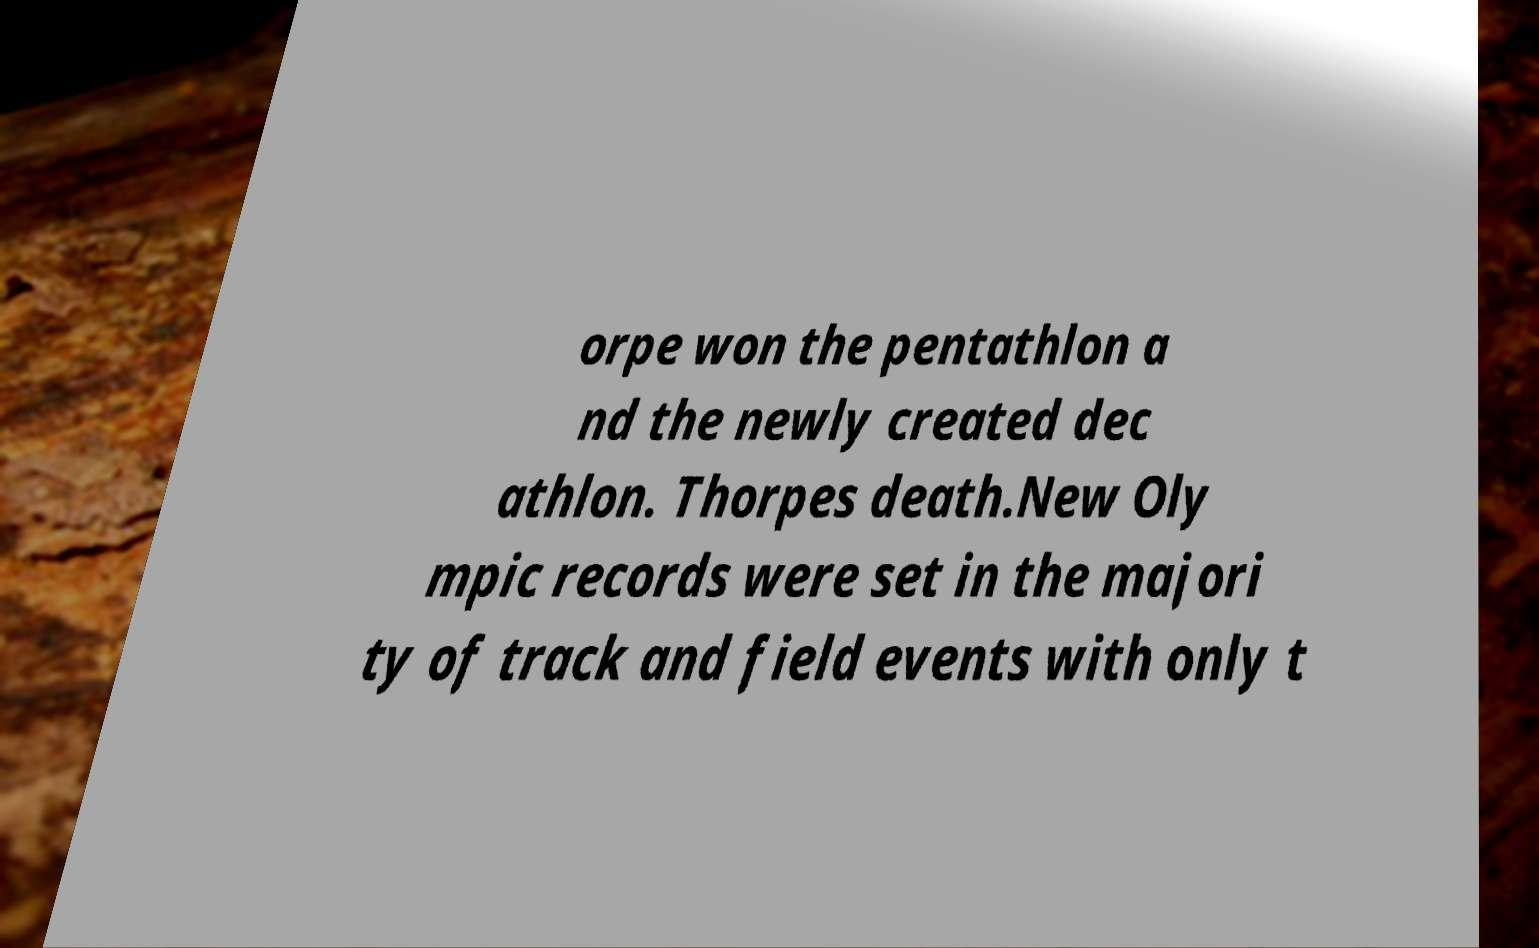Please read and relay the text visible in this image. What does it say? orpe won the pentathlon a nd the newly created dec athlon. Thorpes death.New Oly mpic records were set in the majori ty of track and field events with only t 